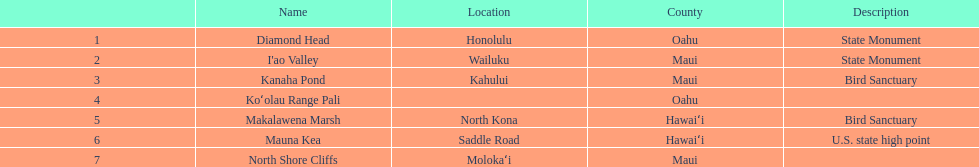How many names do not have a description? 2. 